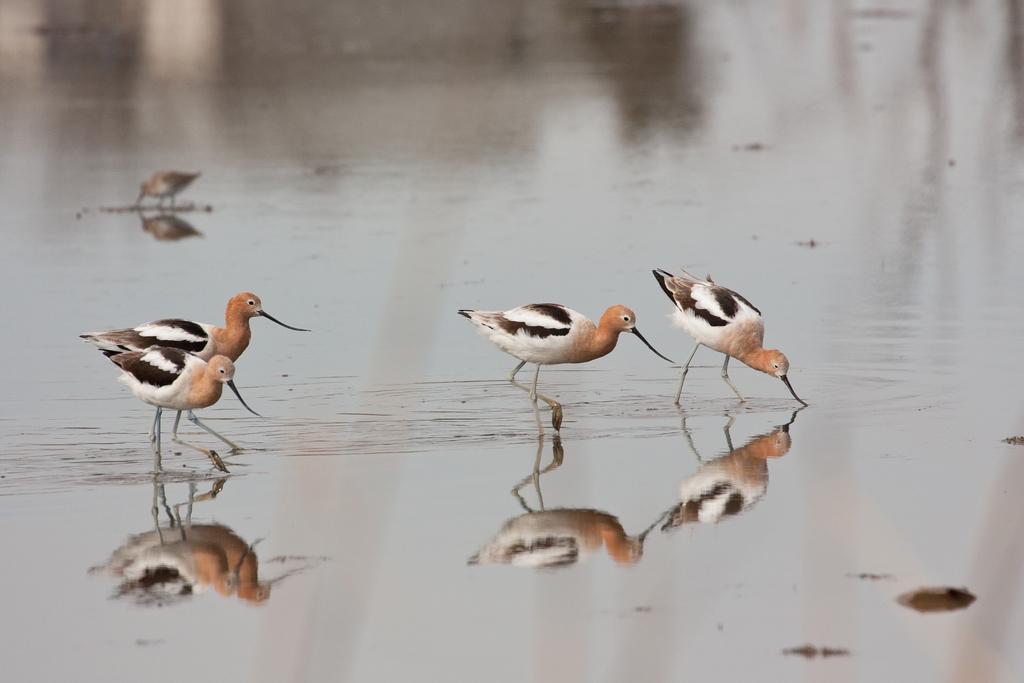In one or two sentences, can you explain what this image depicts? In this picture we can see the water and the birds. We can see the reflection of the birds. 